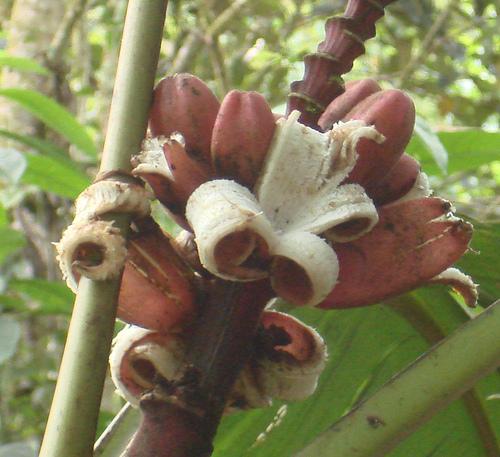What type of plant is this?
Quick response, please. Banana. In what type of environment do you think a plant like this would grow?
Write a very short answer. Tropical. Is this a tropical plant?
Keep it brief. Yes. 